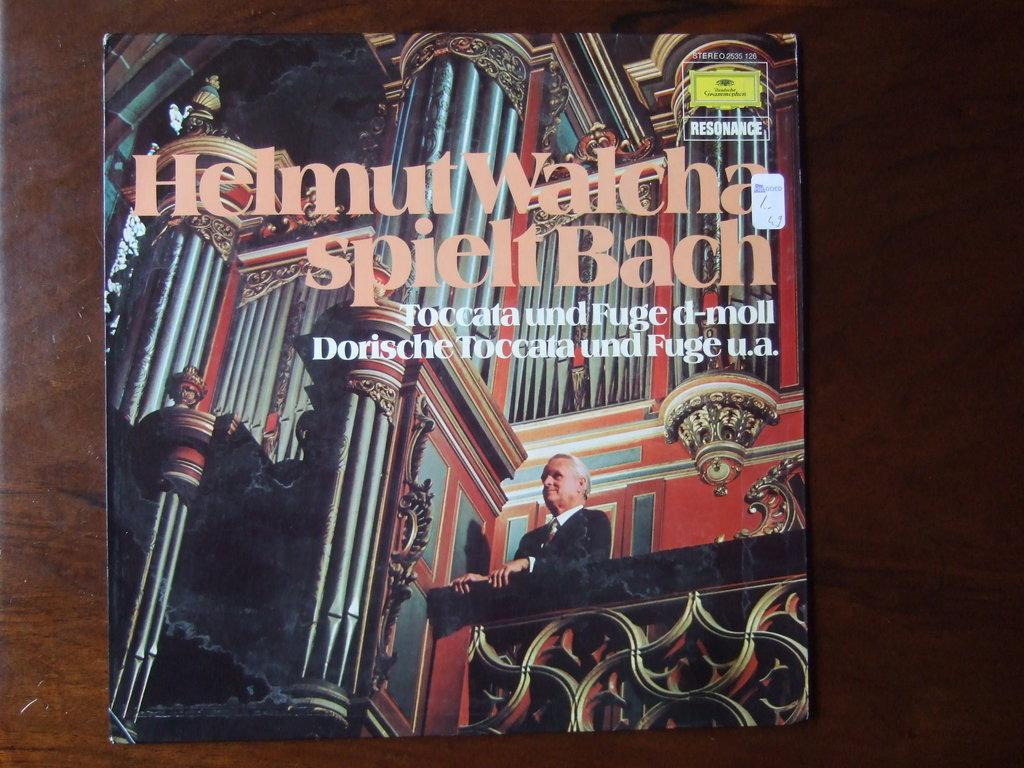<image>
Provide a brief description of the given image. a helmut watch magazine that has a character on it 